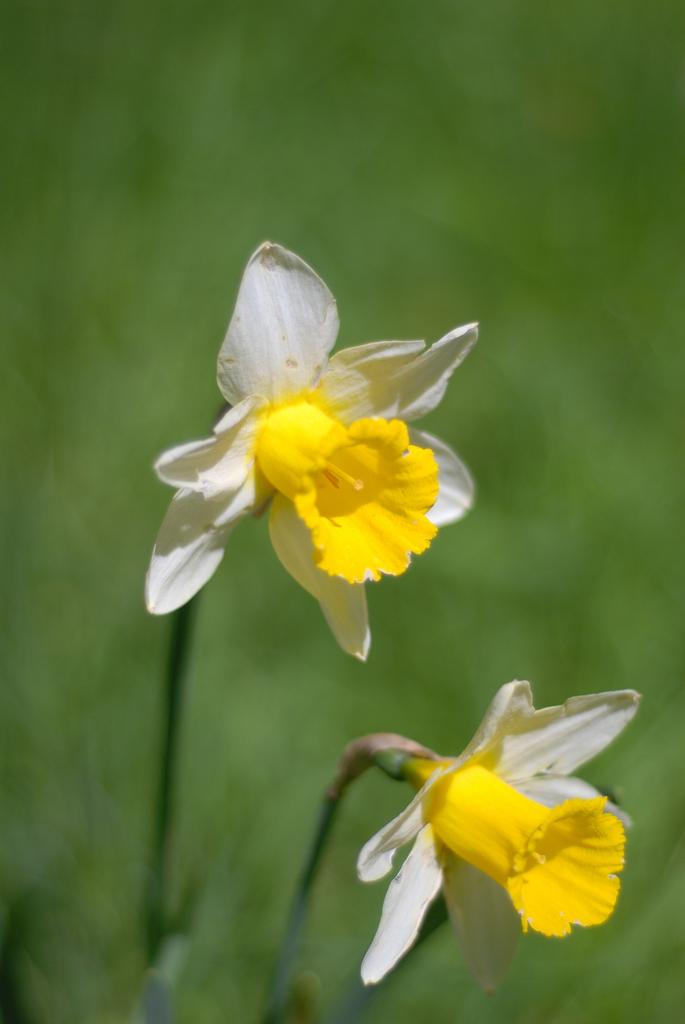What type of living organisms can be seen in the image? There are flowers in the image. Can you describe the background of the image? The background of the image is blurry. What type of polish is being applied to the flowers in the image? There is no polish being applied to the flowers in the image; they are simply flowers. 